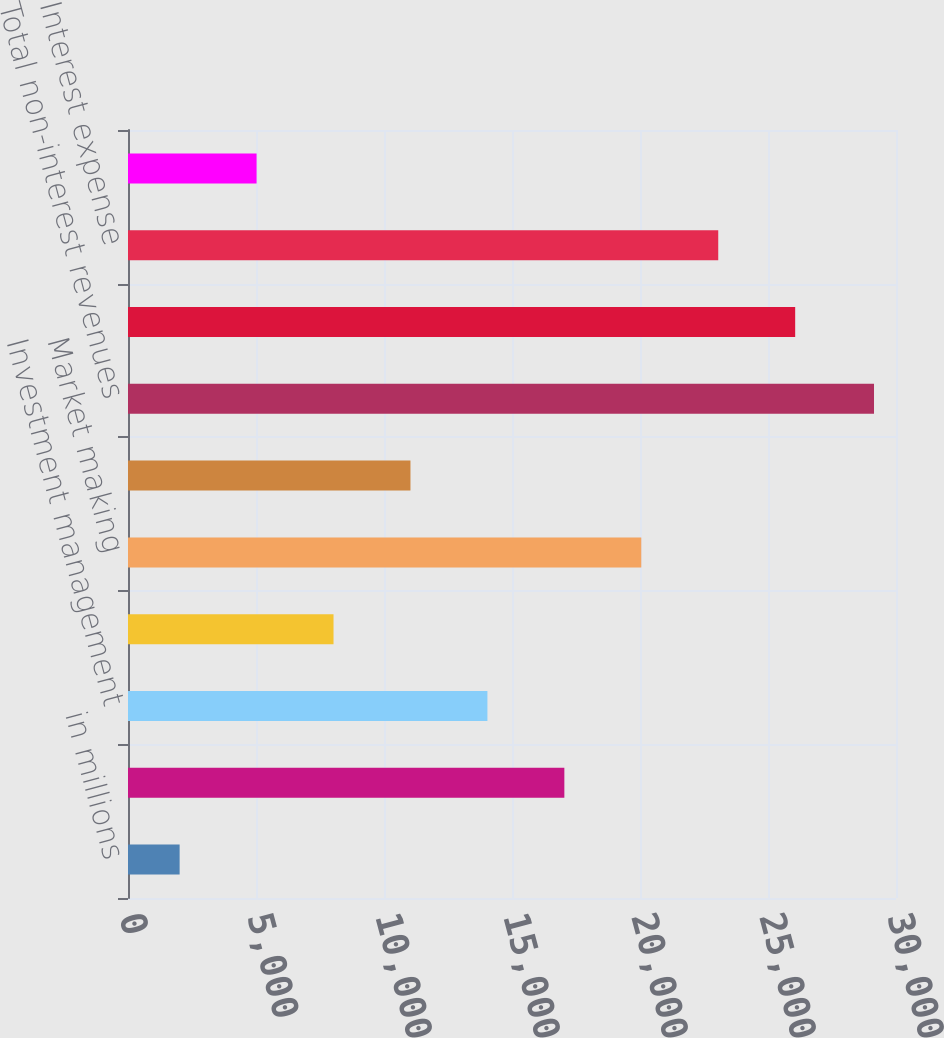<chart> <loc_0><loc_0><loc_500><loc_500><bar_chart><fcel>in millions<fcel>Investment banking<fcel>Investment management<fcel>Commissions and fees<fcel>Market making<fcel>Other principal transactions<fcel>Total non-interest revenues<fcel>Interest income<fcel>Interest expense<fcel>Net interest income<nl><fcel>2017<fcel>17045<fcel>14039.4<fcel>8028.2<fcel>20050.6<fcel>11033.8<fcel>29141<fcel>26061.8<fcel>23056.2<fcel>5022.6<nl></chart> 